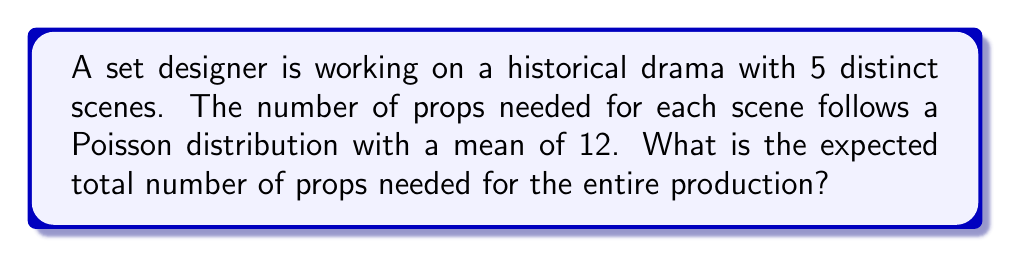Can you solve this math problem? Let's approach this step-by-step:

1) First, we need to understand what the question is asking. We have 5 scenes, and each scene's prop count follows a Poisson distribution with λ = 12.

2) Let's define our random variables:
   Let $X_i$ be the number of props needed for scene i, where i = 1, 2, 3, 4, 5.

3) We're told that each $X_i$ follows a Poisson distribution with mean 12. In mathematical notation:
   $X_i \sim \text{Poisson}(12)$ for i = 1, 2, 3, 4, 5

4) The expected value (mean) of a Poisson distribution is equal to its parameter λ. So:
   $E[X_i] = 12$ for each i

5) We want to find the expected total number of props for all scenes. Let's call this total Y:
   $Y = X_1 + X_2 + X_3 + X_4 + X_5$

6) To find E[Y], we can use the linearity of expectation property, which states that the expected value of a sum is the sum of the expected values:

   $E[Y] = E[X_1 + X_2 + X_3 + X_4 + X_5]$
   $= E[X_1] + E[X_2] + E[X_3] + E[X_4] + E[X_5]$

7) Since each E[X_i] = 12, we have:

   $E[Y] = 12 + 12 + 12 + 12 + 12 = 5 * 12 = 60$

Therefore, the expected total number of props needed for the entire production is 60.
Answer: 60 props 